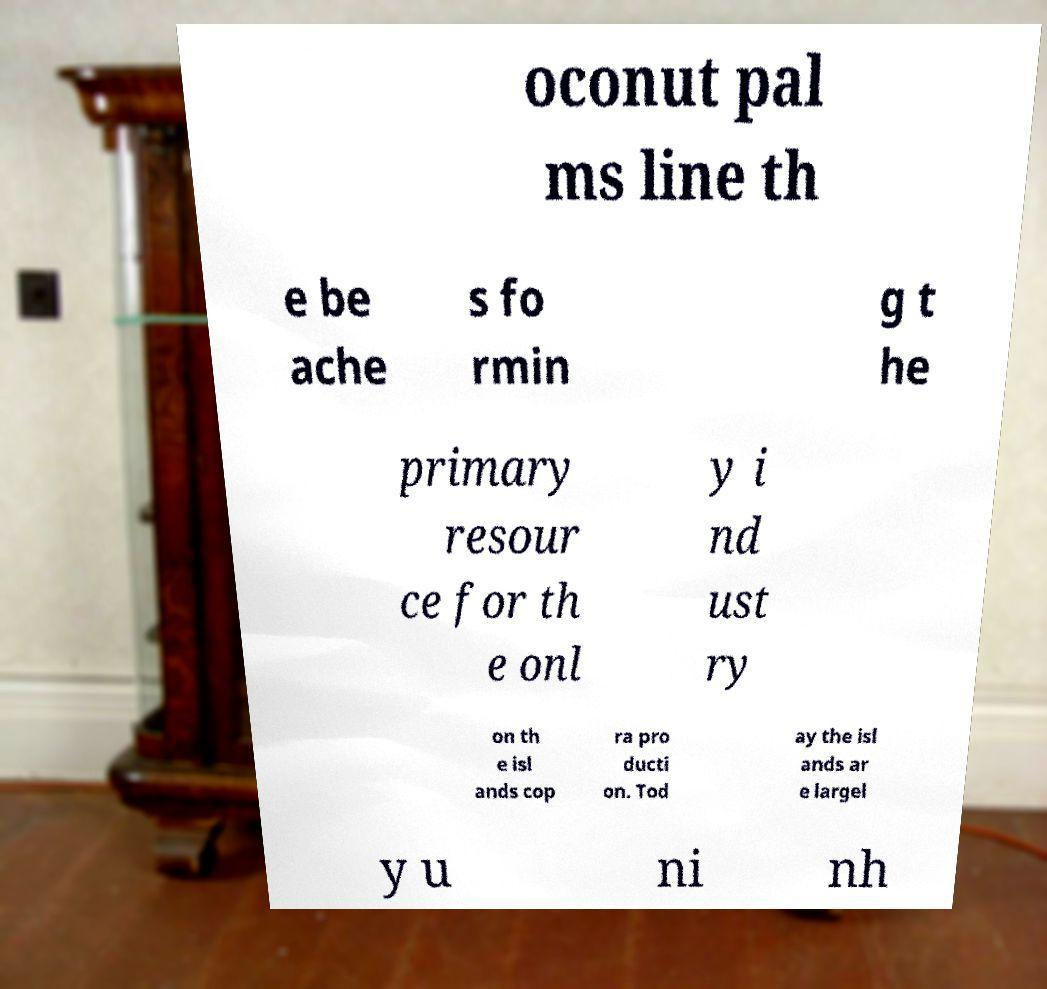There's text embedded in this image that I need extracted. Can you transcribe it verbatim? oconut pal ms line th e be ache s fo rmin g t he primary resour ce for th e onl y i nd ust ry on th e isl ands cop ra pro ducti on. Tod ay the isl ands ar e largel y u ni nh 